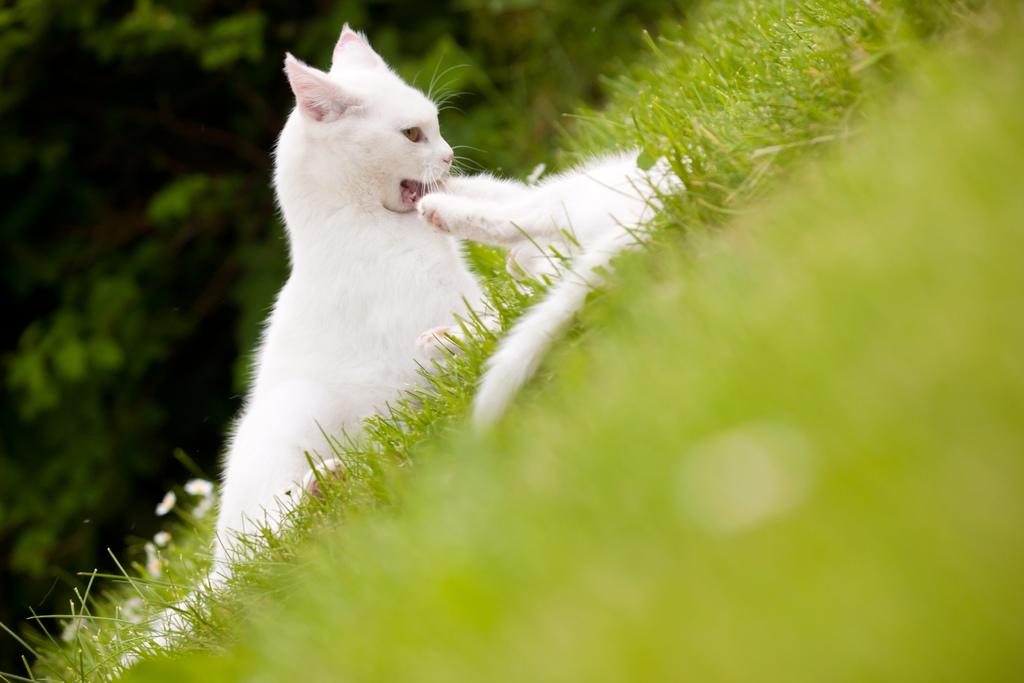How many cats are present in the image? There are two cats in the image. What type of vegetation can be seen in the image? There is grass in the image. Can you describe the background of the image? The background of the image is blurred. How much cord is attached to the cats in the image? There is no cord attached to the cats in the image. 